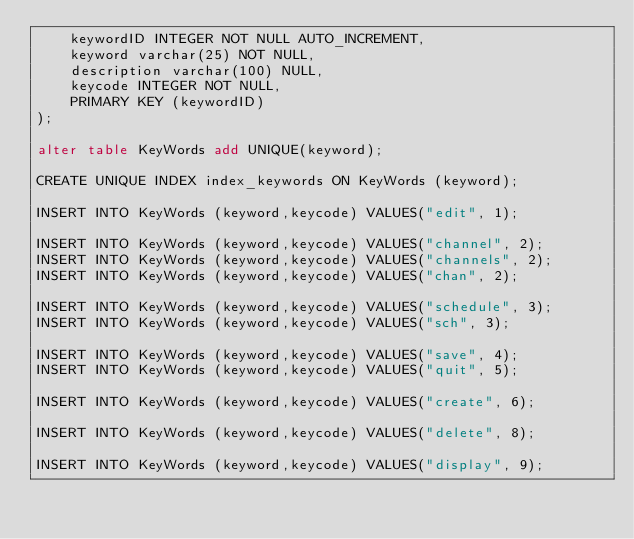Convert code to text. <code><loc_0><loc_0><loc_500><loc_500><_SQL_>    keywordID INTEGER NOT NULL AUTO_INCREMENT,
    keyword varchar(25) NOT NULL,
    description varchar(100) NULL,
    keycode INTEGER NOT NULL,
    PRIMARY KEY (keywordID)
);

alter table KeyWords add UNIQUE(keyword);

CREATE UNIQUE INDEX index_keywords ON KeyWords (keyword);

INSERT INTO KeyWords (keyword,keycode) VALUES("edit", 1);

INSERT INTO KeyWords (keyword,keycode) VALUES("channel", 2);
INSERT INTO KeyWords (keyword,keycode) VALUES("channels", 2);
INSERT INTO KeyWords (keyword,keycode) VALUES("chan", 2);

INSERT INTO KeyWords (keyword,keycode) VALUES("schedule", 3);
INSERT INTO KeyWords (keyword,keycode) VALUES("sch", 3);

INSERT INTO KeyWords (keyword,keycode) VALUES("save", 4);
INSERT INTO KeyWords (keyword,keycode) VALUES("quit", 5);

INSERT INTO KeyWords (keyword,keycode) VALUES("create", 6);

INSERT INTO KeyWords (keyword,keycode) VALUES("delete", 8);

INSERT INTO KeyWords (keyword,keycode) VALUES("display", 9);


</code> 